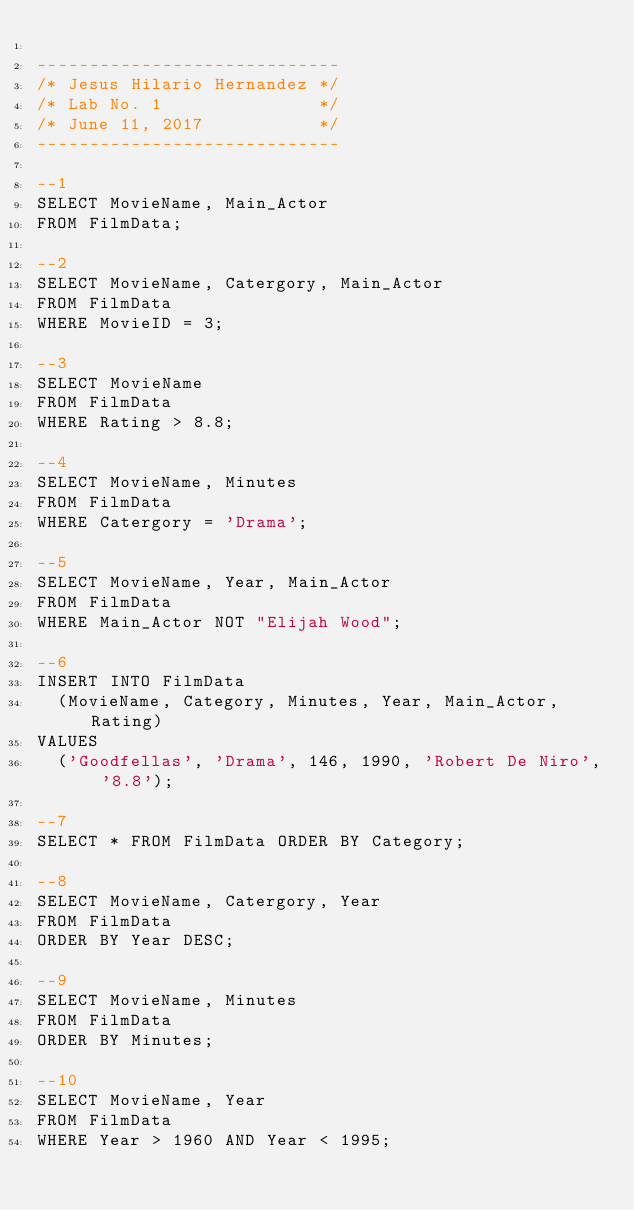<code> <loc_0><loc_0><loc_500><loc_500><_SQL_>
-----------------------------
/* Jesus Hilario Hernandez */
/* Lab No. 1               */
/* June 11, 2017           */
-----------------------------

--1
SELECT MovieName, Main_Actor 
FROM FilmData;

--2
SELECT MovieName, Catergory, Main_Actor
FROM FilmData
WHERE MovieID = 3;

--3
SELECT MovieName
FROM FilmData
WHERE Rating > 8.8;

--4
SELECT MovieName, Minutes
FROM FilmData
WHERE Catergory = 'Drama';

--5
SELECT MovieName, Year, Main_Actor
FROM FilmData
WHERE Main_Actor NOT "Elijah Wood";

--6
INSERT INTO FilmData
  (MovieName, Category, Minutes, Year, Main_Actor, Rating)
VALUES
  ('Goodfellas', 'Drama', 146, 1990, 'Robert De Niro', '8.8');

--7
SELECT * FROM FilmData ORDER BY Category;

--8
SELECT MovieName, Catergory, Year
FROM FilmData
ORDER BY Year DESC;

--9
SELECT MovieName, Minutes
FROM FilmData
ORDER BY Minutes;

--10
SELECT MovieName, Year
FROM FilmData
WHERE Year > 1960 AND Year < 1995;

</code> 